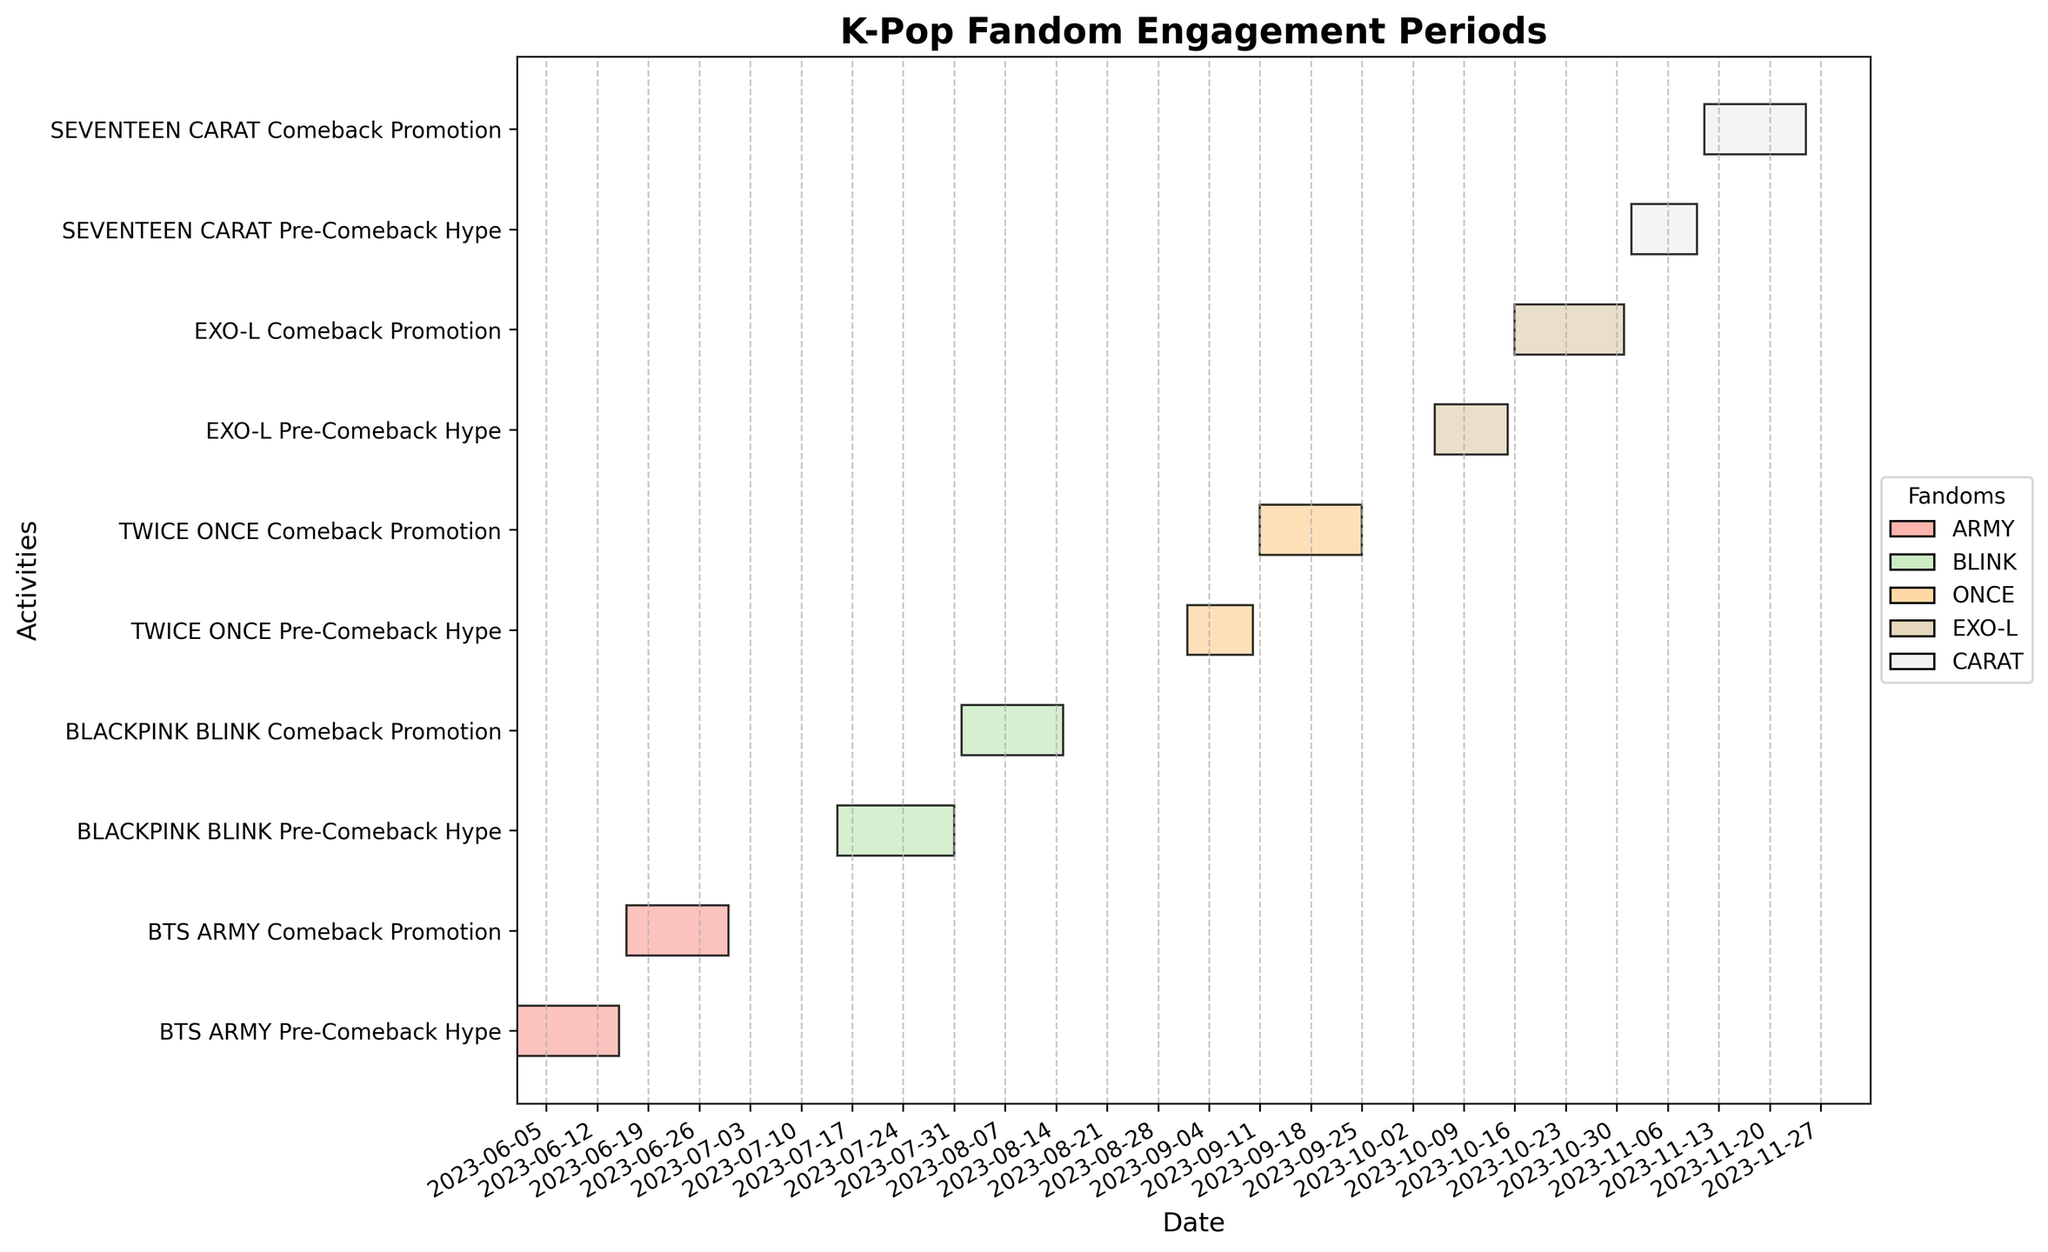What is the total duration of BTS ARMY's engagement periods combined? We need to sum up the number of days for both "BTS ARMY Pre-Comeback Hype" and "BTS ARMY Comeback Promotion". From the chart, "BTS ARMY Pre-Comeback Hype" runs from 2023-06-01 to 2023-06-15, which is 15 days. "BTS ARMY Comeback Promotion" runs from 2023-06-16 to 2023-06-30, which is also 15 days. Adding these together, the total duration is 15 + 15 = 30 days.
Answer: 30 days Which fandom had the longest individual engagement period and how long was it? By examining the bars on the chart, "EXO-L Comeback Promotion" stands out as the longest individual period. It starts on 2023-10-16 and ends on 2023-10-31 which is a duration of 16 days.
Answer: EXO-L, 16 days How does the length of BLACKPINK BLINK's Comeback Promotion compare to their Pre-Comeback Hype? To find the comparison, we look at the duration of each period. "BLACKPINK BLINK Pre-Comeback Hype" runs from 2023-07-15 to 2023-07-31, which is 17 days. "BLACKPINK BLINK Comeback Promotion" runs from 2023-08-01 to 2023-08-15, which is 15 days. So, their Pre-Comeback Hype is 2 days longer than their Comeback Promotion.
Answer: Pre-Comeback Hype is 2 days longer Which month has the highest concentration of engagement periods? To determine the month with the highest concentration, we sum up all periods occurring in each month. June has only BTS ARMY activities (30 days). July has BLACKPINK BLINK's Pre-Comeback Hype starting mid-month. August only includes the latter half of BLINK's activity. September sees full and partial engagement from TWICE ONCE (25 days). October has partial engagement from EXO-L (26 days). November has SEVENTEEN CARAT's full engagement (25 days). Summing all engagement periods, October has the highest concentration with 31 days.
Answer: October How many fandoms have separated pre-comeback hype and comeback promotion periods? We count the distinct separated periods for each fandom. From the bars in the chart, BTS ARMY, BLACKPINK BLINK, TWICE ONCE, EXO-L, and SEVENTEEN CARAT each have distinct pre-comeback hype and comeback promotion periods. This is a total of 5 fandoms.
Answer: 5 fandoms 